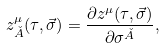Convert formula to latex. <formula><loc_0><loc_0><loc_500><loc_500>z ^ { \mu } _ { \check { A } } ( \tau , \vec { \sigma } ) = \frac { \partial z ^ { \mu } ( \tau , \vec { \sigma } ) } { \partial \sigma ^ { \check { A } } } ,</formula> 